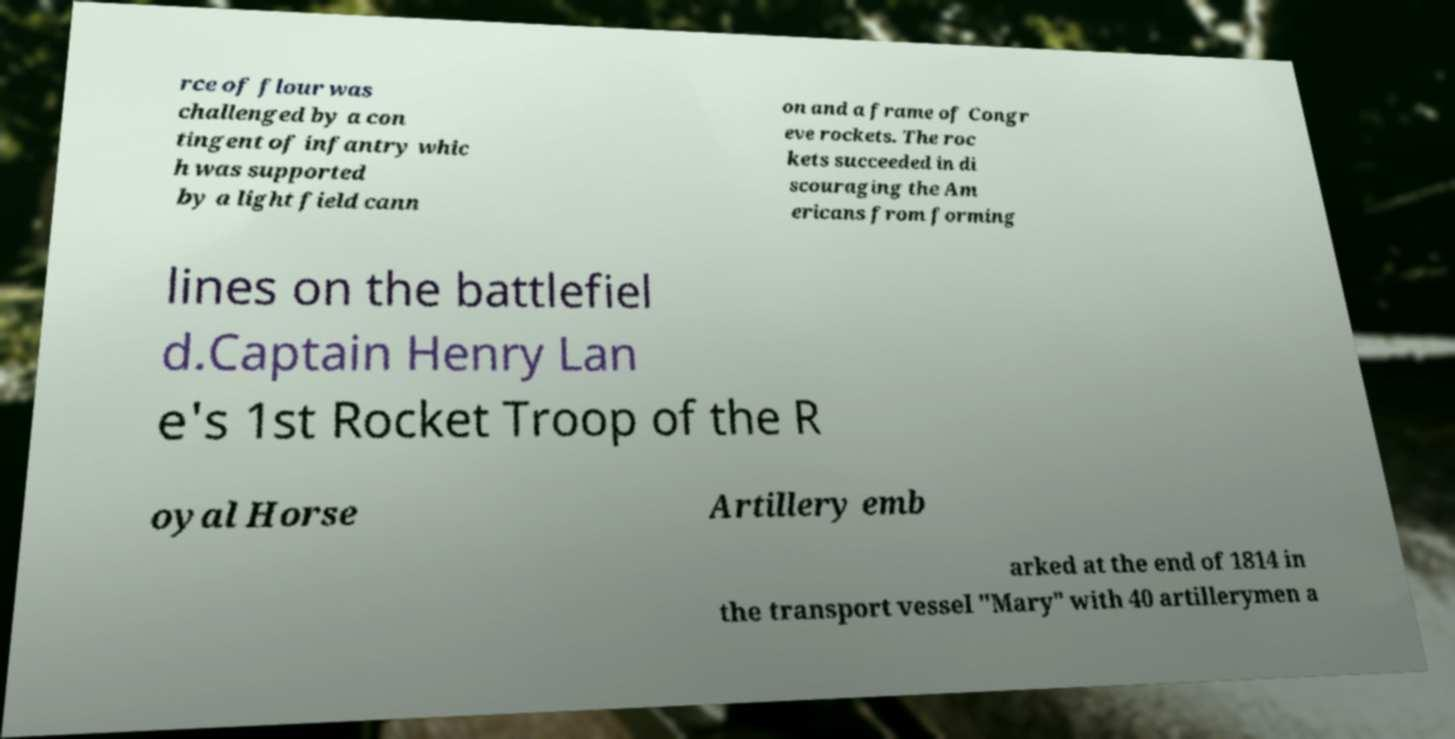Can you read and provide the text displayed in the image?This photo seems to have some interesting text. Can you extract and type it out for me? rce of flour was challenged by a con tingent of infantry whic h was supported by a light field cann on and a frame of Congr eve rockets. The roc kets succeeded in di scouraging the Am ericans from forming lines on the battlefiel d.Captain Henry Lan e's 1st Rocket Troop of the R oyal Horse Artillery emb arked at the end of 1814 in the transport vessel "Mary" with 40 artillerymen a 